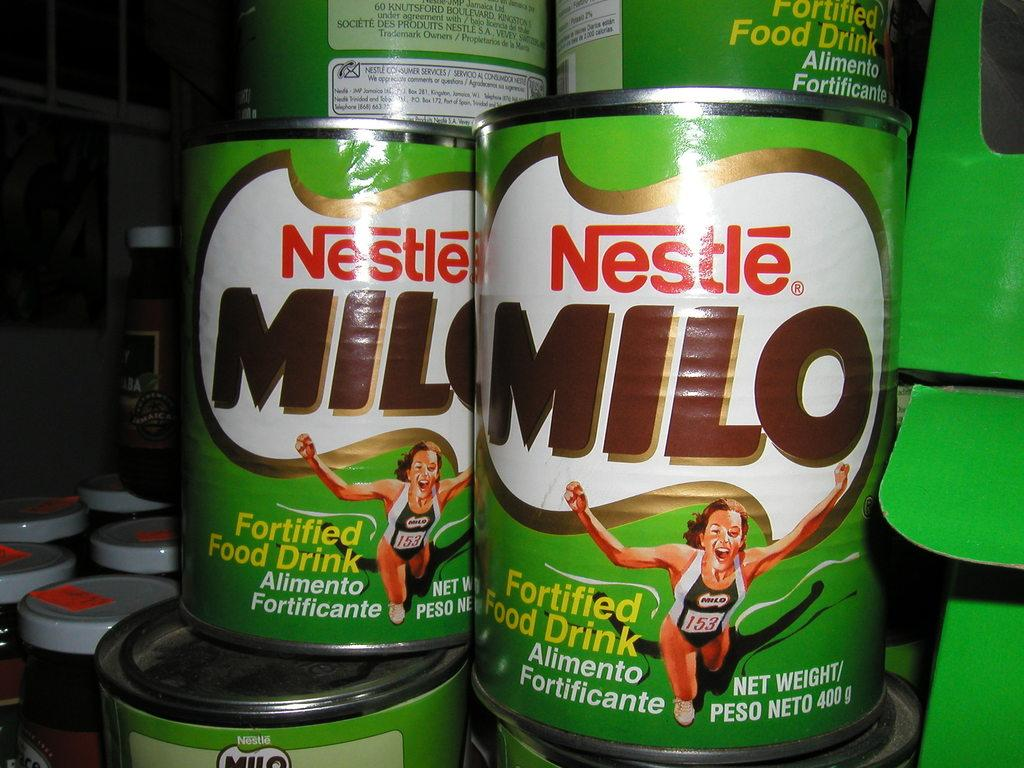<image>
Relay a brief, clear account of the picture shown. Multiple canned foods from the brand Nestle are stacked and next to other containers of food. 